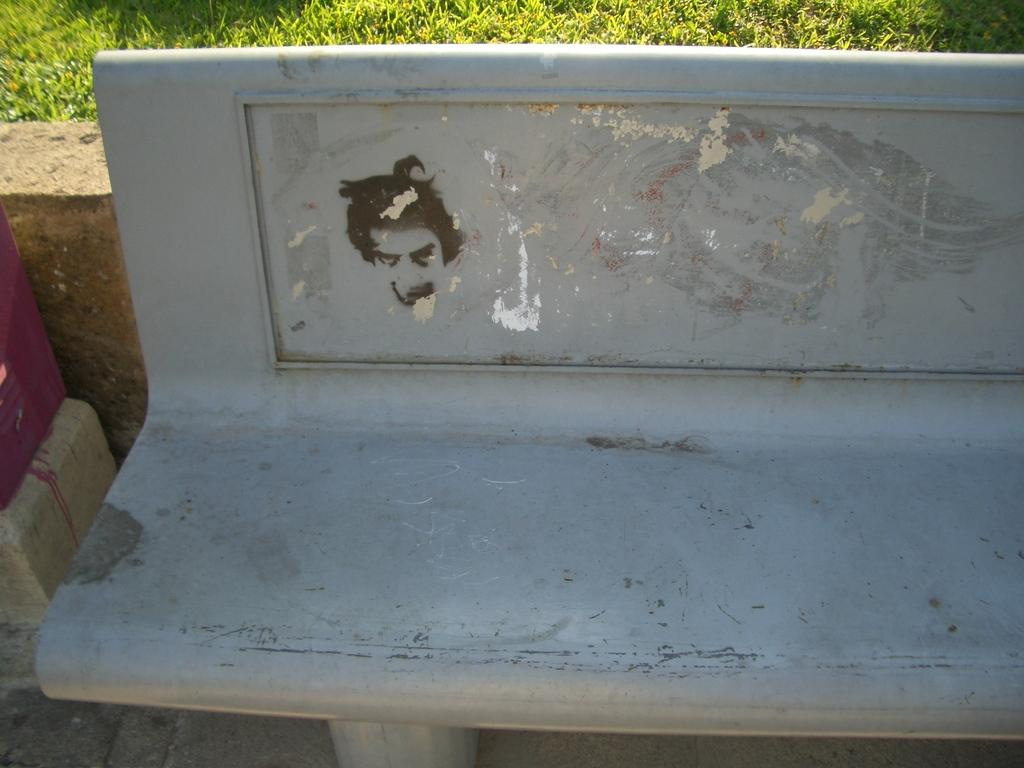What type of seating is present in the image? There is a bench in the image. Where is the bench located? The bench is on the ground. What type of vegetation can be seen in the image? There is grass visible in the image. What type of stage is visible in the image? There is no stage present in the image. Is there a donkey grazing on the grass in the image? There is no donkey present in the image. 